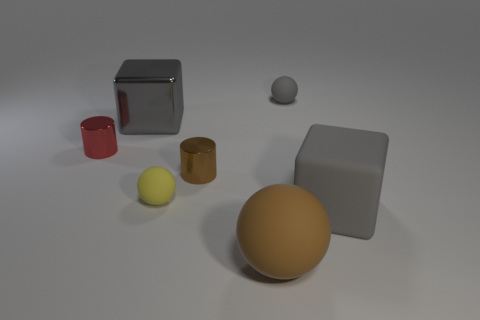There is a ball that is left of the small brown cylinder; how big is it?
Your response must be concise. Small. What number of blue things are matte blocks or tiny things?
Keep it short and to the point. 0. Is there anything else that is the same material as the brown ball?
Make the answer very short. Yes. What material is the big object that is the same shape as the small gray rubber object?
Provide a short and direct response. Rubber. Are there the same number of tiny yellow spheres that are in front of the large gray metallic object and cyan blocks?
Provide a short and direct response. No. There is a gray thing that is behind the small red cylinder and on the right side of the tiny brown metallic cylinder; how big is it?
Your answer should be very brief. Small. Is there any other thing of the same color as the big rubber sphere?
Offer a terse response. Yes. There is a gray block that is in front of the cube on the left side of the gray sphere; what size is it?
Provide a short and direct response. Large. There is a object that is in front of the small gray thing and on the right side of the big sphere; what is its color?
Ensure brevity in your answer.  Gray. What number of other things are there of the same size as the red cylinder?
Give a very brief answer. 3. 